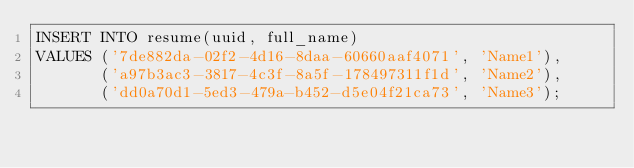Convert code to text. <code><loc_0><loc_0><loc_500><loc_500><_SQL_>INSERT INTO resume(uuid, full_name)
VALUES ('7de882da-02f2-4d16-8daa-60660aaf4071', 'Name1'),
       ('a97b3ac3-3817-4c3f-8a5f-178497311f1d', 'Name2'),
       ('dd0a70d1-5ed3-479a-b452-d5e04f21ca73', 'Name3');
</code> 